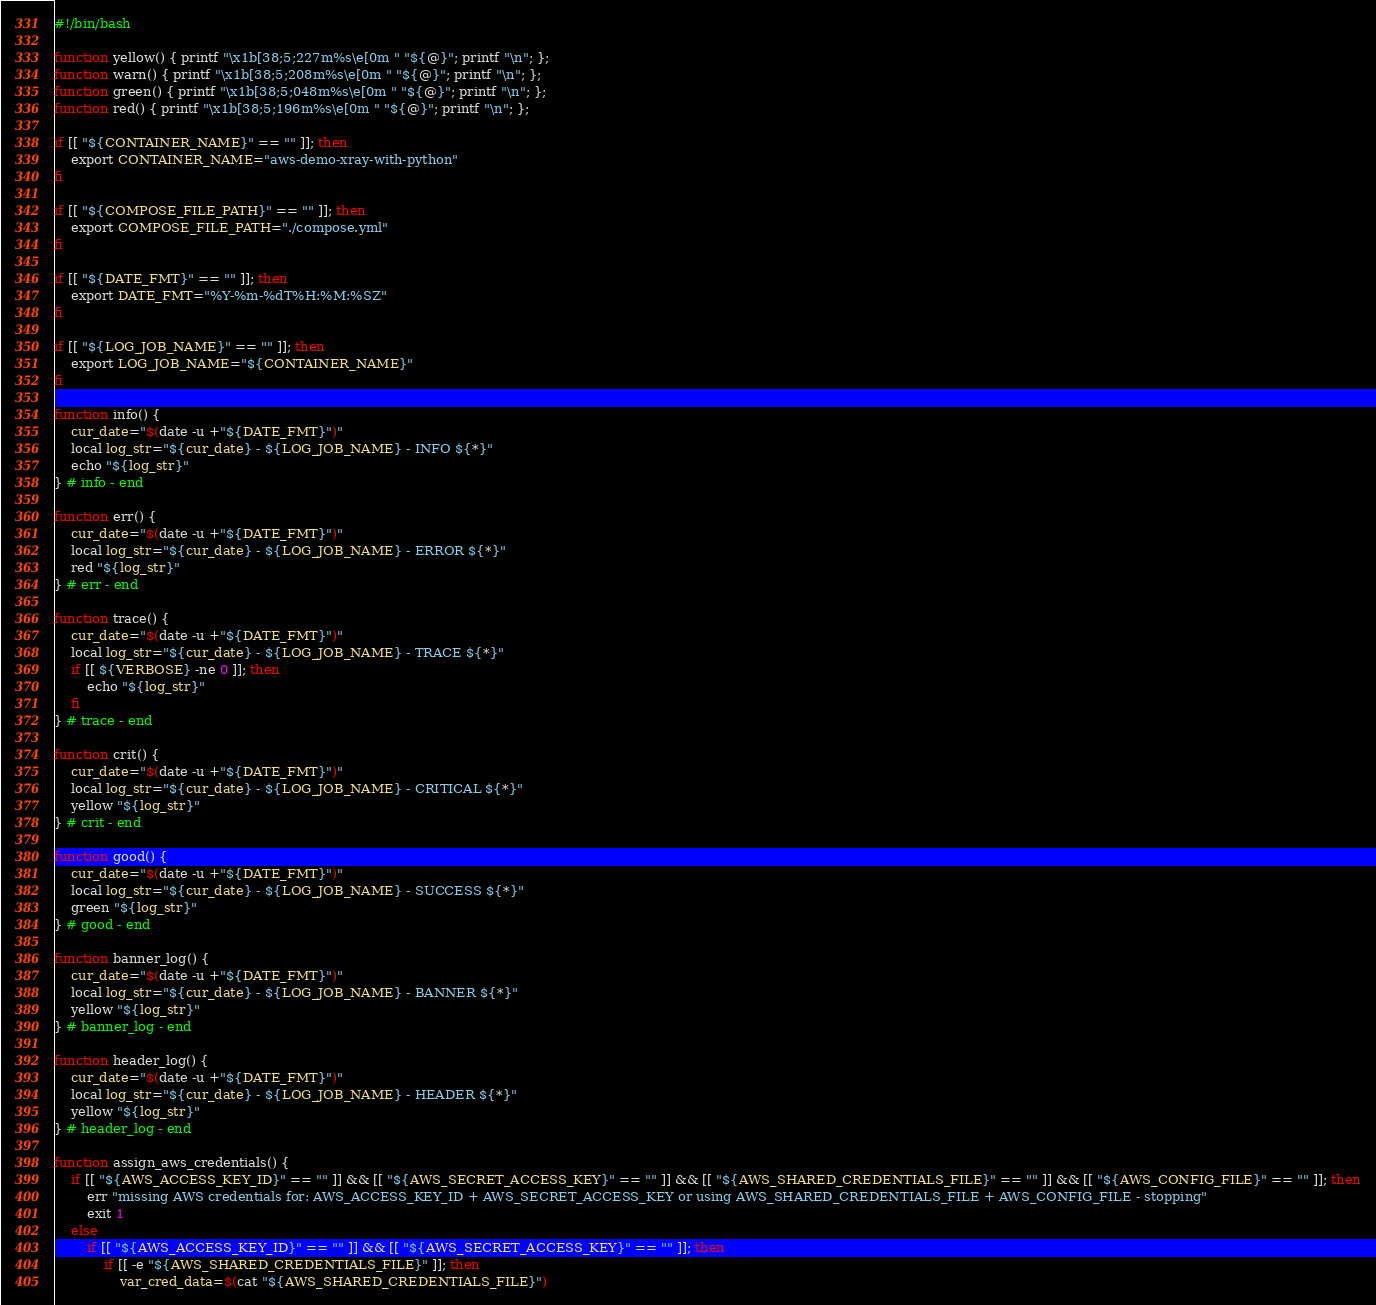<code> <loc_0><loc_0><loc_500><loc_500><_Bash_>#!/bin/bash

function yellow() { printf "\x1b[38;5;227m%s\e[0m " "${@}"; printf "\n"; };
function warn() { printf "\x1b[38;5;208m%s\e[0m " "${@}"; printf "\n"; };
function green() { printf "\x1b[38;5;048m%s\e[0m " "${@}"; printf "\n"; };
function red() { printf "\x1b[38;5;196m%s\e[0m " "${@}"; printf "\n"; };

if [[ "${CONTAINER_NAME}" == "" ]]; then
    export CONTAINER_NAME="aws-demo-xray-with-python"
fi

if [[ "${COMPOSE_FILE_PATH}" == "" ]]; then
    export COMPOSE_FILE_PATH="./compose.yml"
fi

if [[ "${DATE_FMT}" == "" ]]; then
    export DATE_FMT="%Y-%m-%dT%H:%M:%SZ"
fi

if [[ "${LOG_JOB_NAME}" == "" ]]; then
    export LOG_JOB_NAME="${CONTAINER_NAME}"
fi

function info() {
    cur_date="$(date -u +"${DATE_FMT}")"
    local log_str="${cur_date} - ${LOG_JOB_NAME} - INFO ${*}"
    echo "${log_str}"
} # info - end

function err() {
    cur_date="$(date -u +"${DATE_FMT}")"
    local log_str="${cur_date} - ${LOG_JOB_NAME} - ERROR ${*}"
    red "${log_str}"
} # err - end

function trace() {
    cur_date="$(date -u +"${DATE_FMT}")"
    local log_str="${cur_date} - ${LOG_JOB_NAME} - TRACE ${*}"
    if [[ ${VERBOSE} -ne 0 ]]; then
        echo "${log_str}"
    fi
} # trace - end

function crit() {
    cur_date="$(date -u +"${DATE_FMT}")"
    local log_str="${cur_date} - ${LOG_JOB_NAME} - CRITICAL ${*}"
    yellow "${log_str}"
} # crit - end

function good() {
    cur_date="$(date -u +"${DATE_FMT}")"
    local log_str="${cur_date} - ${LOG_JOB_NAME} - SUCCESS ${*}"
    green "${log_str}"
} # good - end

function banner_log() {
    cur_date="$(date -u +"${DATE_FMT}")"
    local log_str="${cur_date} - ${LOG_JOB_NAME} - BANNER ${*}"
    yellow "${log_str}"
} # banner_log - end

function header_log() {
    cur_date="$(date -u +"${DATE_FMT}")"
    local log_str="${cur_date} - ${LOG_JOB_NAME} - HEADER ${*}"
    yellow "${log_str}"
} # header_log - end

function assign_aws_credentials() {
    if [[ "${AWS_ACCESS_KEY_ID}" == "" ]] && [[ "${AWS_SECRET_ACCESS_KEY}" == "" ]] && [[ "${AWS_SHARED_CREDENTIALS_FILE}" == "" ]] && [[ "${AWS_CONFIG_FILE}" == "" ]]; then
        err "missing AWS credentials for: AWS_ACCESS_KEY_ID + AWS_SECRET_ACCESS_KEY or using AWS_SHARED_CREDENTIALS_FILE + AWS_CONFIG_FILE - stopping"
        exit 1
    else
        if [[ "${AWS_ACCESS_KEY_ID}" == "" ]] && [[ "${AWS_SECRET_ACCESS_KEY}" == "" ]]; then
            if [[ -e "${AWS_SHARED_CREDENTIALS_FILE}" ]]; then
                var_cred_data=$(cat "${AWS_SHARED_CREDENTIALS_FILE}")</code> 